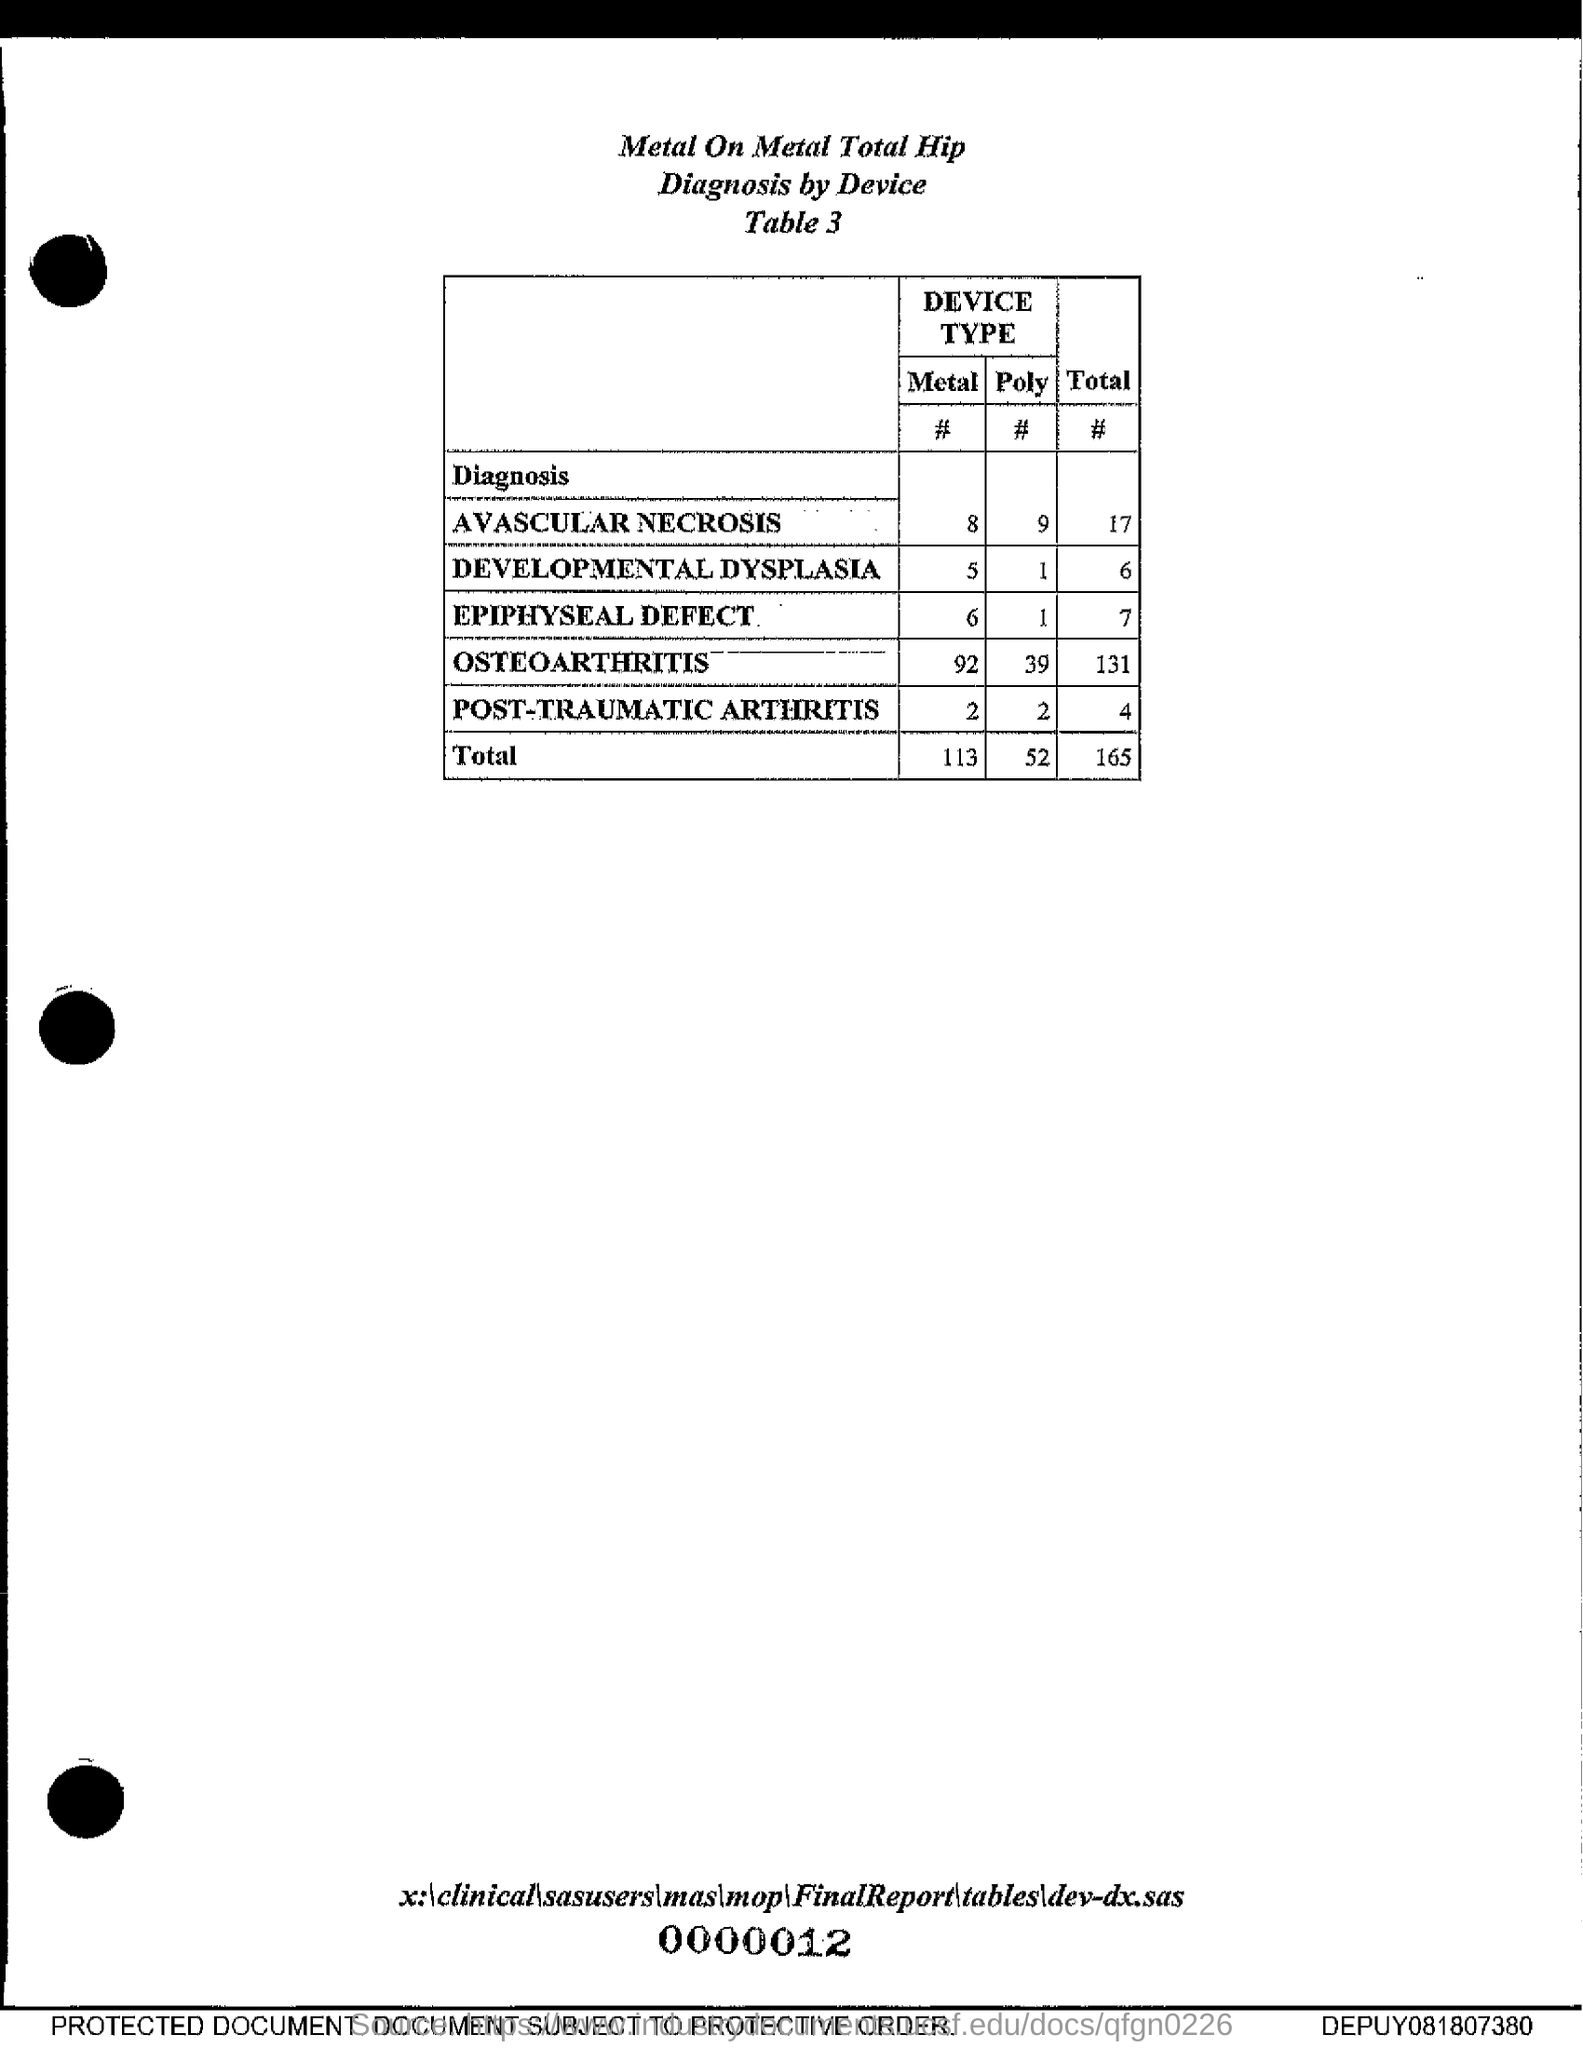What is the total number of EPIPHYSEAL DEFECT?
Your response must be concise. 7. What is the title given?
Offer a very short reply. Metal On Metal Total Hip Diagnosis by Device. What is the number of metal device for avascular necrosis?
Your response must be concise. 8. 